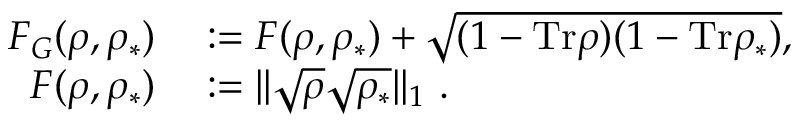<formula> <loc_0><loc_0><loc_500><loc_500>\begin{array} { r l } { F _ { G } ( \rho , \rho _ { \ast } ) } & \colon = F ( \rho , \rho _ { \ast } ) + \sqrt { ( 1 - T r \rho ) ( 1 - T r \rho _ { \ast } ) } , } \\ { F ( \rho , \rho _ { \ast } ) } & \colon = | | \sqrt { \rho } \sqrt { \rho _ { \ast } } | | _ { 1 } . } \end{array}</formula> 